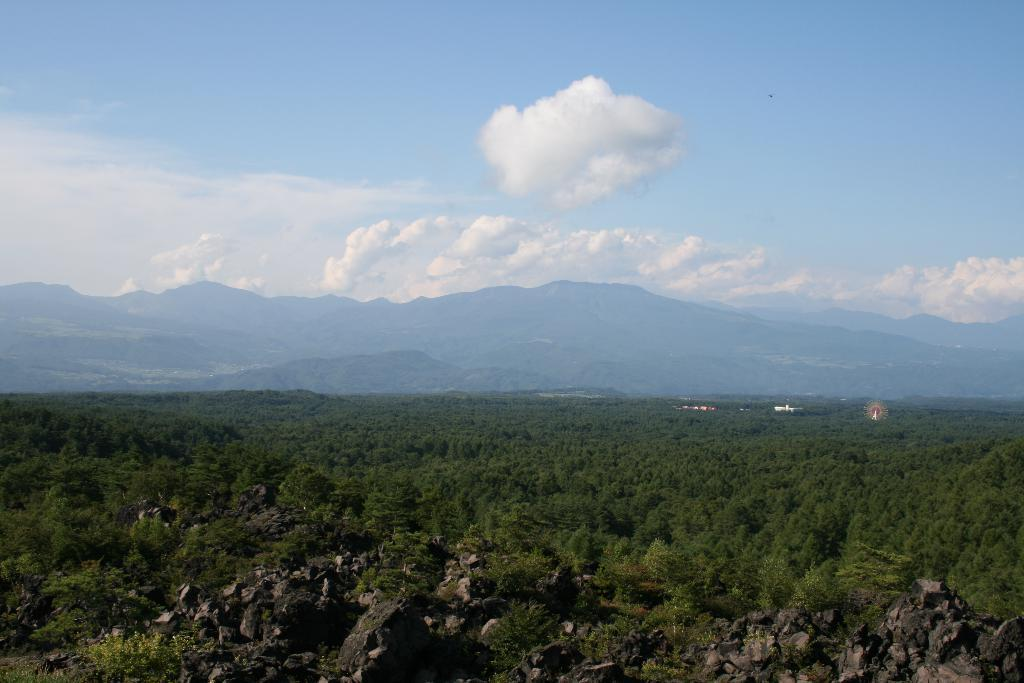What type of natural features are present at the bottom of the image? There are trees and rocks at the bottom of the image. What type of geographical features can be seen in the background of the image? There are mountains in the background of the image. What type of man-made structures are visible in the background of the image? There are buildings in the background of the image. What is visible at the top of the image? The sky is visible at the top of the image. What type of engine can be seen powering the trees in the image? There is no engine present in the image, as trees are natural features and do not require engines to function. What type of pear is hanging from the rocks in the image? There is no pear present in the image; it features trees and rocks, not fruit. 